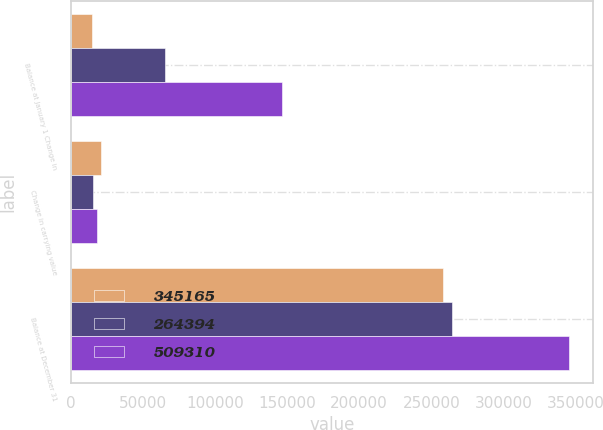Convert chart. <chart><loc_0><loc_0><loc_500><loc_500><stacked_bar_chart><ecel><fcel>Balance at January 1 Change in<fcel>Change in carrying value<fcel>Balance at December 31<nl><fcel>345165<fcel>14544<fcel>20658<fcel>258280<nl><fcel>264394<fcel>65524<fcel>15247<fcel>264394<nl><fcel>509310<fcel>146284<fcel>17861<fcel>345165<nl></chart> 